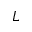Convert formula to latex. <formula><loc_0><loc_0><loc_500><loc_500>L</formula> 